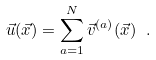Convert formula to latex. <formula><loc_0><loc_0><loc_500><loc_500>\vec { u } ( \vec { x } ) = \sum _ { a = 1 } ^ { N } \vec { v } ^ { ( a ) } ( \vec { x } ) \ .</formula> 